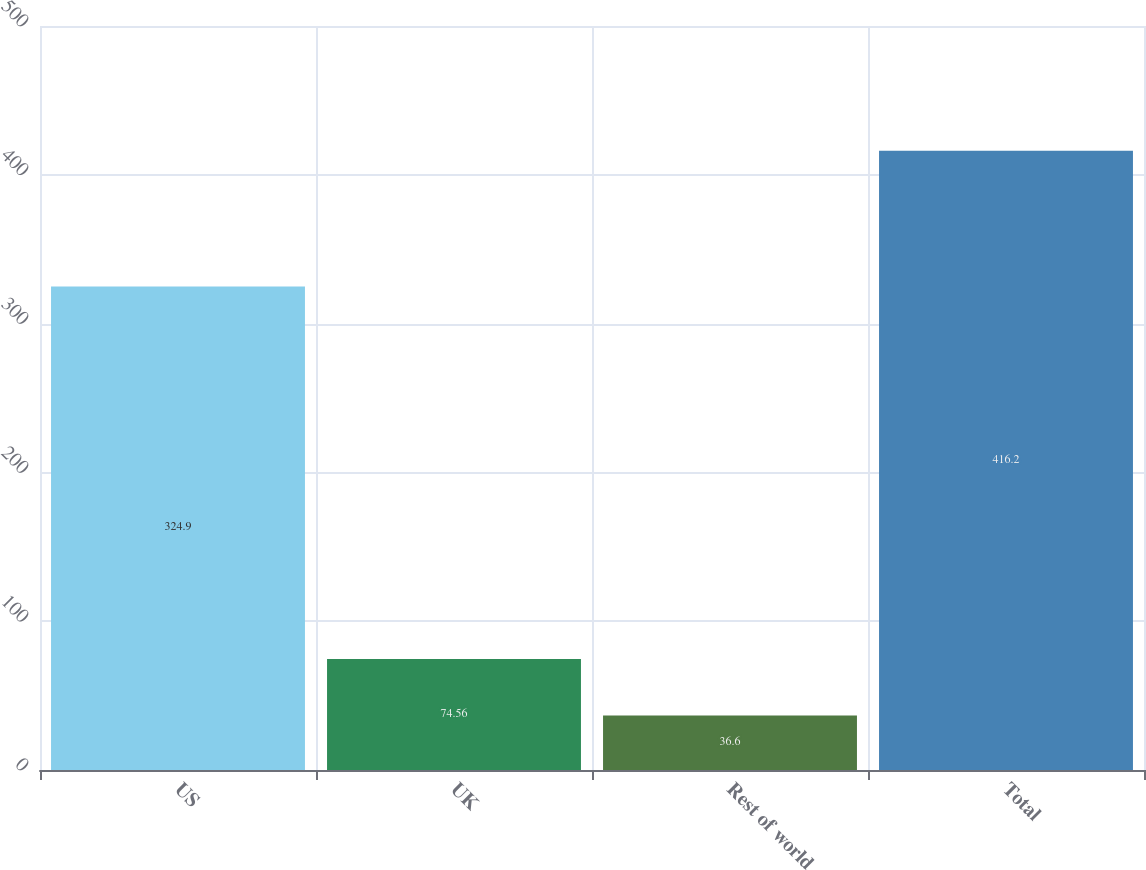<chart> <loc_0><loc_0><loc_500><loc_500><bar_chart><fcel>US<fcel>UK<fcel>Rest of world<fcel>Total<nl><fcel>324.9<fcel>74.56<fcel>36.6<fcel>416.2<nl></chart> 